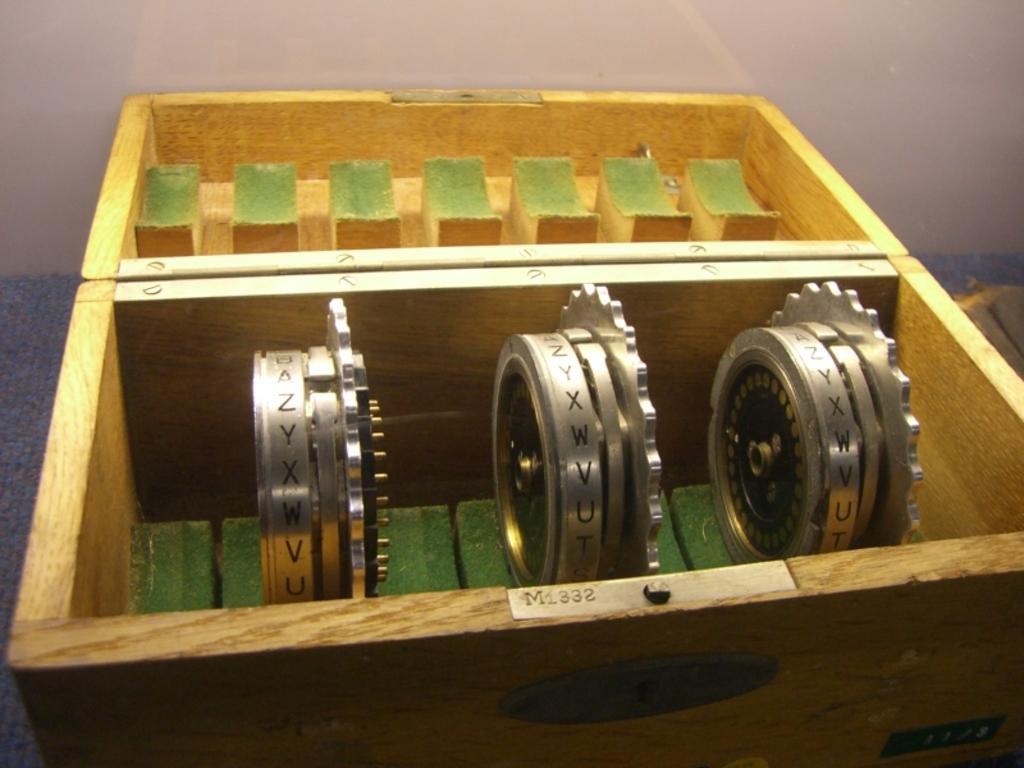Please provide a concise description of this image. In the picture I can see the rotating gears in the wooden box. In the background, I can see the wall. 